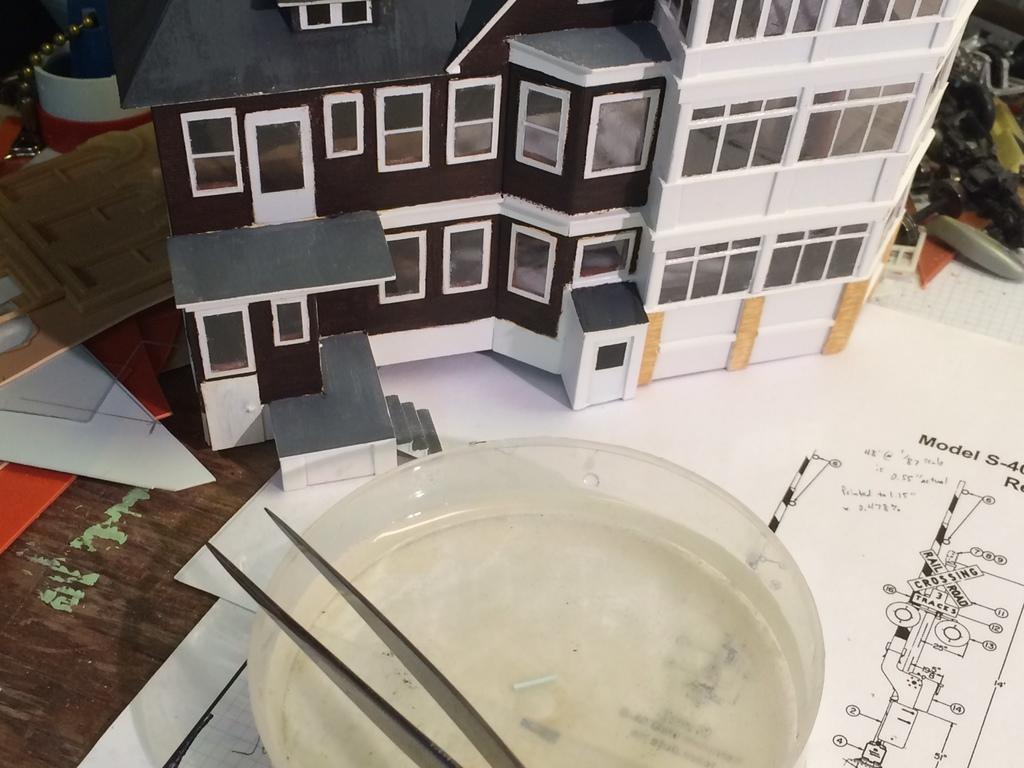What type of structures can be seen in the image? There are buildings depicted in the image. What type of items are present on the table in the image? There are text papers and a bowl on the table in the image. Can you describe any other objects on the table in the image? There are other objects on the table in the image, but their specific nature is not mentioned in the provided facts. What type of fiction is being written on the yarn in the image? There is no yarn or fiction present in the image. How many hands are visible in the image? There is no mention of hands in the provided facts, so we cannot determine their presence or quantity in the image. 